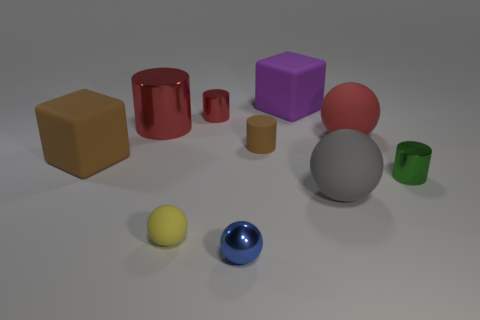Subtract all blocks. Subtract all brown blocks. How many objects are left? 7 Add 2 large purple cubes. How many large purple cubes are left? 3 Add 3 small purple objects. How many small purple objects exist? 3 Subtract all green cylinders. How many cylinders are left? 3 Subtract all big cylinders. How many cylinders are left? 3 Subtract 0 green blocks. How many objects are left? 10 Subtract all cylinders. How many objects are left? 6 Subtract 1 cubes. How many cubes are left? 1 Subtract all blue cylinders. Subtract all blue blocks. How many cylinders are left? 4 Subtract all purple blocks. How many brown spheres are left? 0 